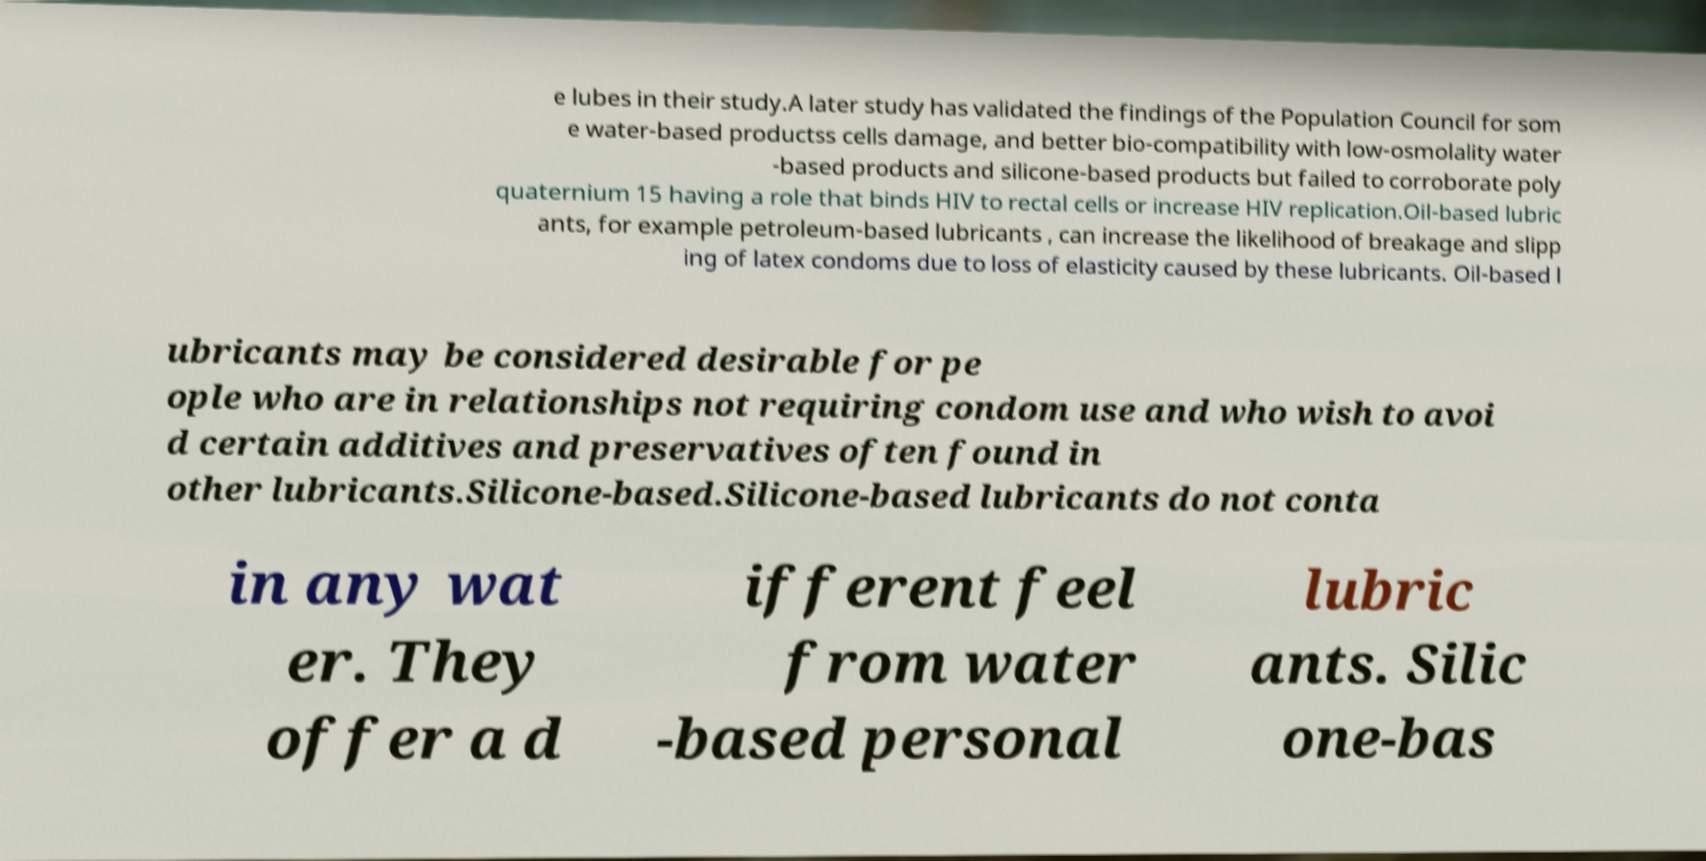I need the written content from this picture converted into text. Can you do that? e lubes in their study.A later study has validated the findings of the Population Council for som e water-based productss cells damage, and better bio-compatibility with low-osmolality water -based products and silicone-based products but failed to corroborate poly quaternium 15 having a role that binds HIV to rectal cells or increase HIV replication.Oil-based lubric ants, for example petroleum-based lubricants , can increase the likelihood of breakage and slipp ing of latex condoms due to loss of elasticity caused by these lubricants. Oil-based l ubricants may be considered desirable for pe ople who are in relationships not requiring condom use and who wish to avoi d certain additives and preservatives often found in other lubricants.Silicone-based.Silicone-based lubricants do not conta in any wat er. They offer a d ifferent feel from water -based personal lubric ants. Silic one-bas 